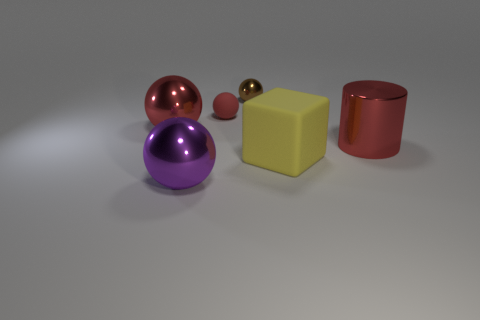Is the shape of the red thing to the left of the small red object the same as the shiny thing that is behind the rubber ball?
Give a very brief answer. Yes. There is another tiny ball that is made of the same material as the purple ball; what color is it?
Ensure brevity in your answer.  Brown. Are there fewer large purple metal objects that are on the left side of the large yellow object than blocks?
Offer a terse response. No. There is a red cylinder that is behind the big sphere that is in front of the red thing on the left side of the small red sphere; what is its size?
Provide a short and direct response. Large. Is the purple object that is in front of the small brown thing made of the same material as the tiny red sphere?
Make the answer very short. No. There is a large sphere that is the same color as the metallic cylinder; what is its material?
Ensure brevity in your answer.  Metal. Is there any other thing that is the same shape as the large purple thing?
Make the answer very short. Yes. How many things are either tiny cyan matte things or small brown metal objects?
Offer a terse response. 1. What size is the red metal object that is the same shape as the red matte thing?
Ensure brevity in your answer.  Large. Are there any other things that have the same size as the brown metallic thing?
Offer a very short reply. Yes. 